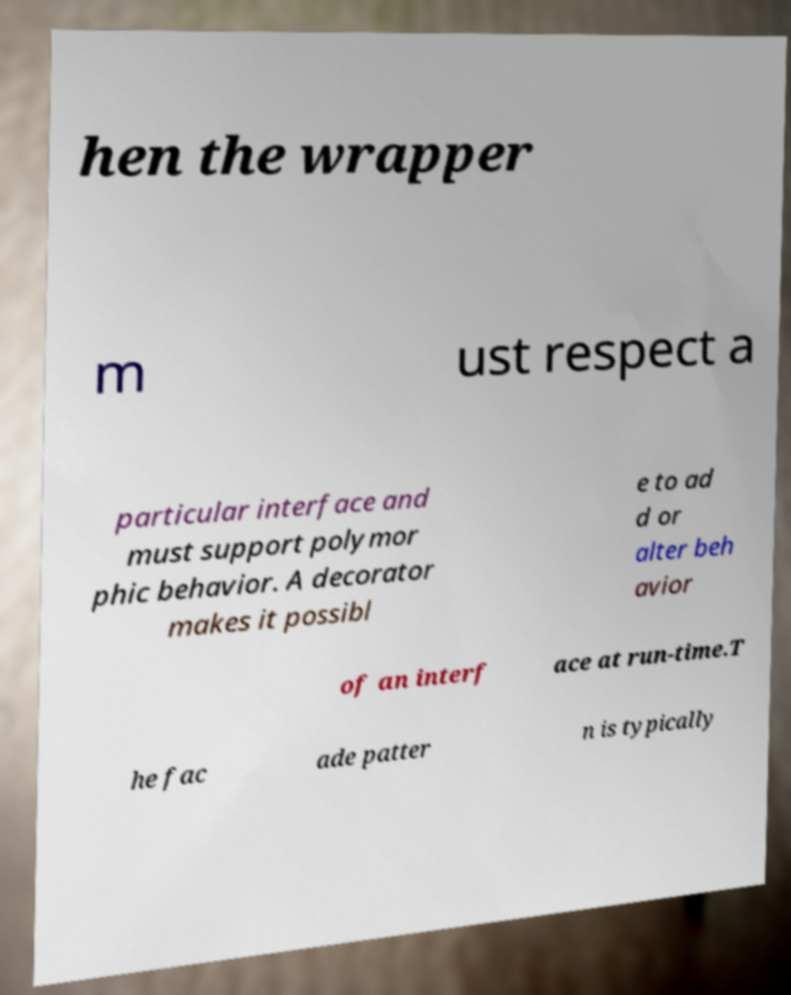Can you accurately transcribe the text from the provided image for me? hen the wrapper m ust respect a particular interface and must support polymor phic behavior. A decorator makes it possibl e to ad d or alter beh avior of an interf ace at run-time.T he fac ade patter n is typically 